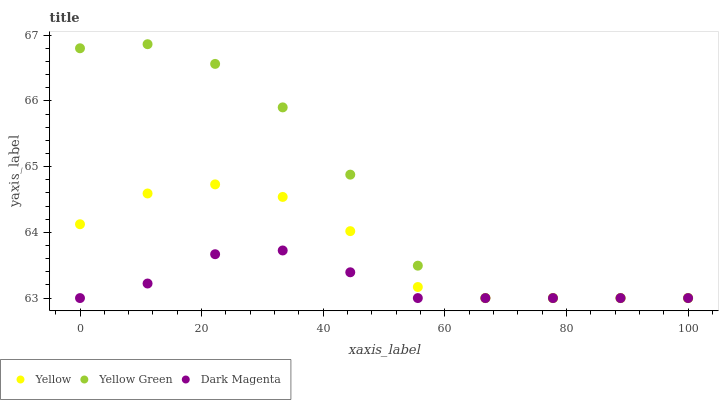Does Dark Magenta have the minimum area under the curve?
Answer yes or no. Yes. Does Yellow Green have the maximum area under the curve?
Answer yes or no. Yes. Does Yellow have the minimum area under the curve?
Answer yes or no. No. Does Yellow have the maximum area under the curve?
Answer yes or no. No. Is Dark Magenta the smoothest?
Answer yes or no. Yes. Is Yellow Green the roughest?
Answer yes or no. Yes. Is Yellow the smoothest?
Answer yes or no. No. Is Yellow the roughest?
Answer yes or no. No. Does Yellow Green have the lowest value?
Answer yes or no. Yes. Does Yellow Green have the highest value?
Answer yes or no. Yes. Does Yellow have the highest value?
Answer yes or no. No. Does Yellow Green intersect Yellow?
Answer yes or no. Yes. Is Yellow Green less than Yellow?
Answer yes or no. No. Is Yellow Green greater than Yellow?
Answer yes or no. No. 